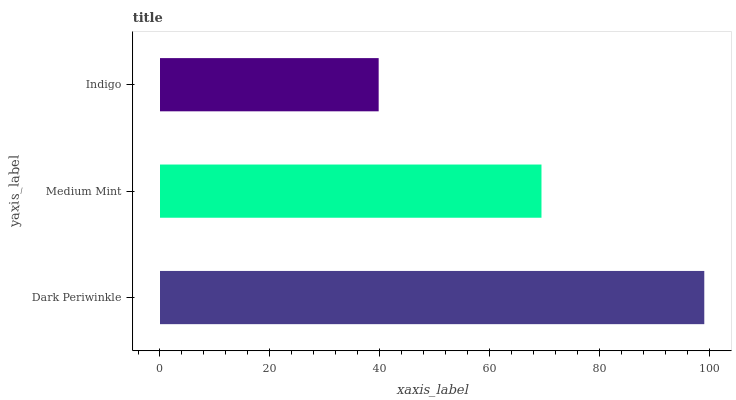Is Indigo the minimum?
Answer yes or no. Yes. Is Dark Periwinkle the maximum?
Answer yes or no. Yes. Is Medium Mint the minimum?
Answer yes or no. No. Is Medium Mint the maximum?
Answer yes or no. No. Is Dark Periwinkle greater than Medium Mint?
Answer yes or no. Yes. Is Medium Mint less than Dark Periwinkle?
Answer yes or no. Yes. Is Medium Mint greater than Dark Periwinkle?
Answer yes or no. No. Is Dark Periwinkle less than Medium Mint?
Answer yes or no. No. Is Medium Mint the high median?
Answer yes or no. Yes. Is Medium Mint the low median?
Answer yes or no. Yes. Is Indigo the high median?
Answer yes or no. No. Is Indigo the low median?
Answer yes or no. No. 